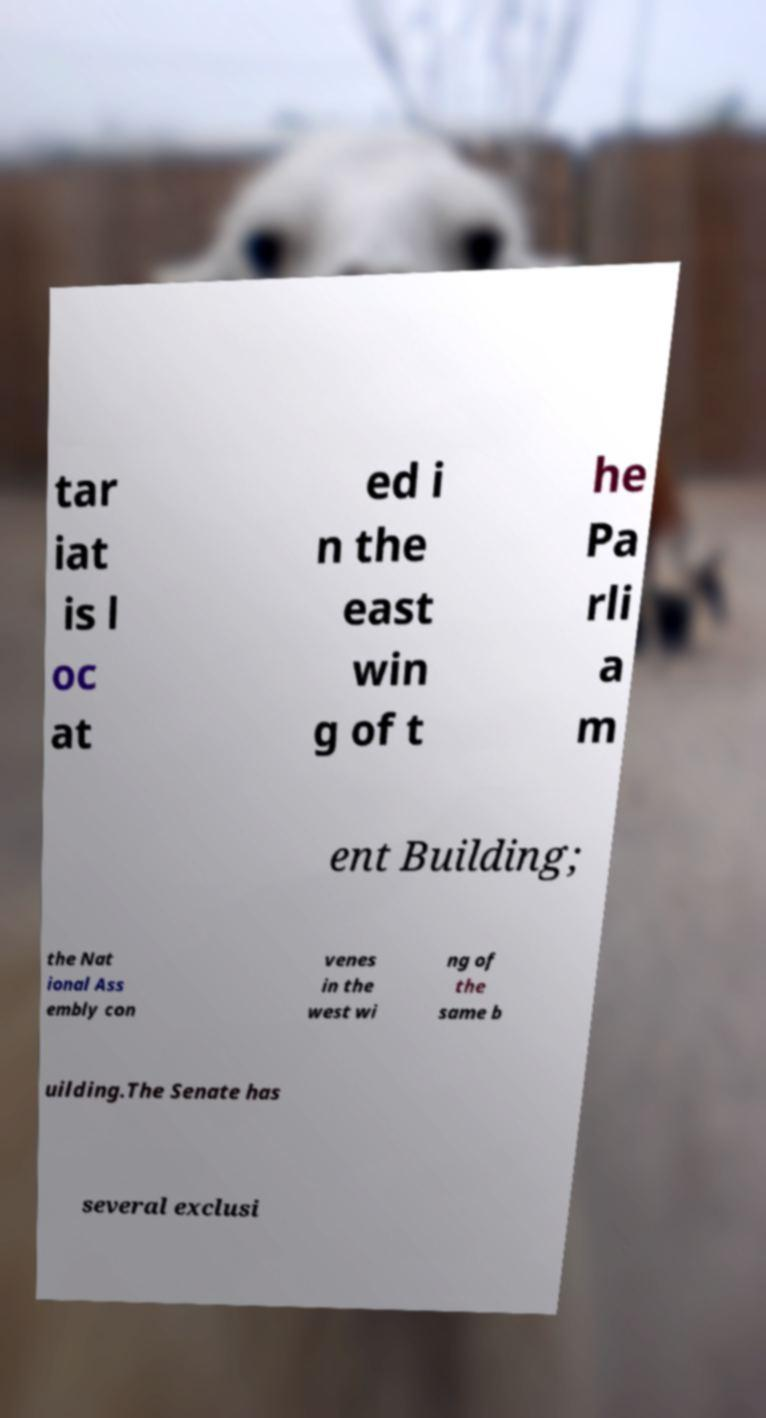I need the written content from this picture converted into text. Can you do that? tar iat is l oc at ed i n the east win g of t he Pa rli a m ent Building; the Nat ional Ass embly con venes in the west wi ng of the same b uilding.The Senate has several exclusi 